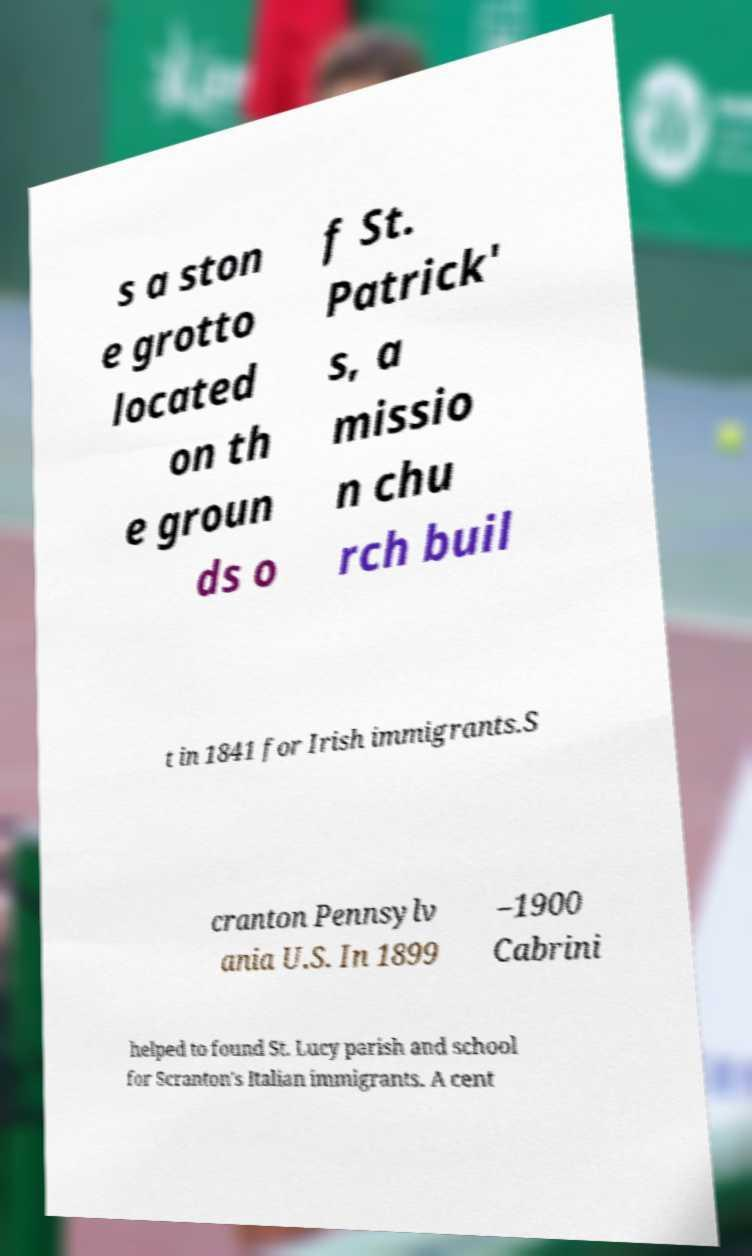Please identify and transcribe the text found in this image. s a ston e grotto located on th e groun ds o f St. Patrick' s, a missio n chu rch buil t in 1841 for Irish immigrants.S cranton Pennsylv ania U.S. In 1899 –1900 Cabrini helped to found St. Lucy parish and school for Scranton's Italian immigrants. A cent 